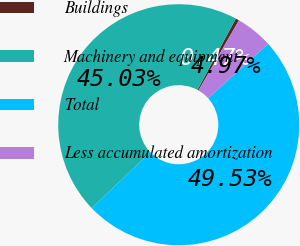<chart> <loc_0><loc_0><loc_500><loc_500><pie_chart><fcel>Buildings<fcel>Machinery and equipment<fcel>Total<fcel>Less accumulated amortization<nl><fcel>0.47%<fcel>45.03%<fcel>49.53%<fcel>4.97%<nl></chart> 